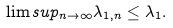Convert formula to latex. <formula><loc_0><loc_0><loc_500><loc_500>\lim s u p _ { n \rightarrow \infty } \lambda _ { 1 , n } \leq \lambda _ { 1 } .</formula> 